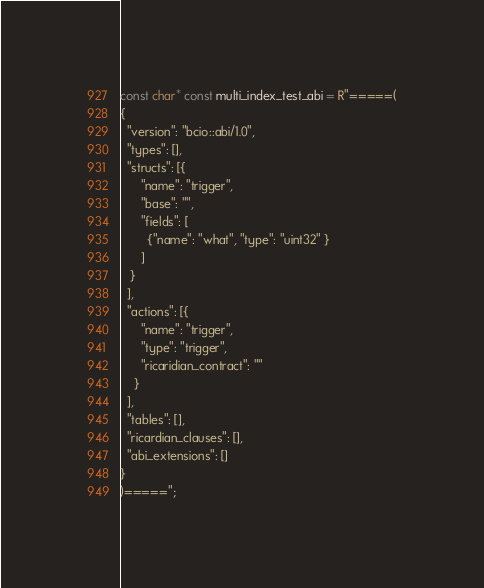<code> <loc_0><loc_0><loc_500><loc_500><_C++_>const char* const multi_index_test_abi = R"=====(
{
  "version": "bcio::abi/1.0",
  "types": [],
  "structs": [{
      "name": "trigger",
      "base": "",
      "fields": [
        {"name": "what", "type": "uint32" }
      ]
   }
  ],
  "actions": [{
      "name": "trigger",
      "type": "trigger",
      "ricaridian_contract": ""
    }
  ],
  "tables": [],
  "ricardian_clauses": [],
  "abi_extensions": []
}
)=====";
</code> 